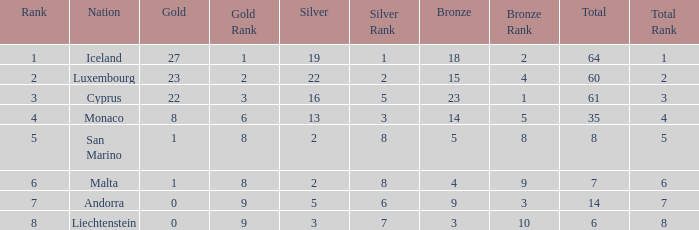Where does Iceland rank with under 19 silvers? None. 